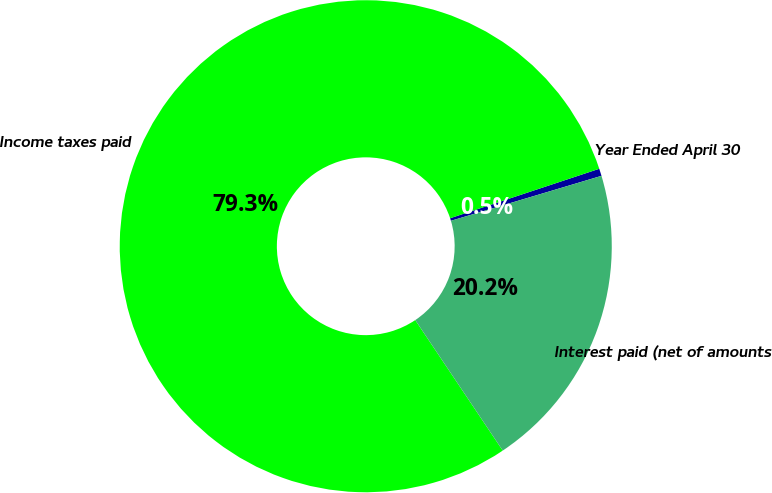Convert chart. <chart><loc_0><loc_0><loc_500><loc_500><pie_chart><fcel>Year Ended April 30<fcel>Income taxes paid<fcel>Interest paid (net of amounts<nl><fcel>0.48%<fcel>79.3%<fcel>20.22%<nl></chart> 